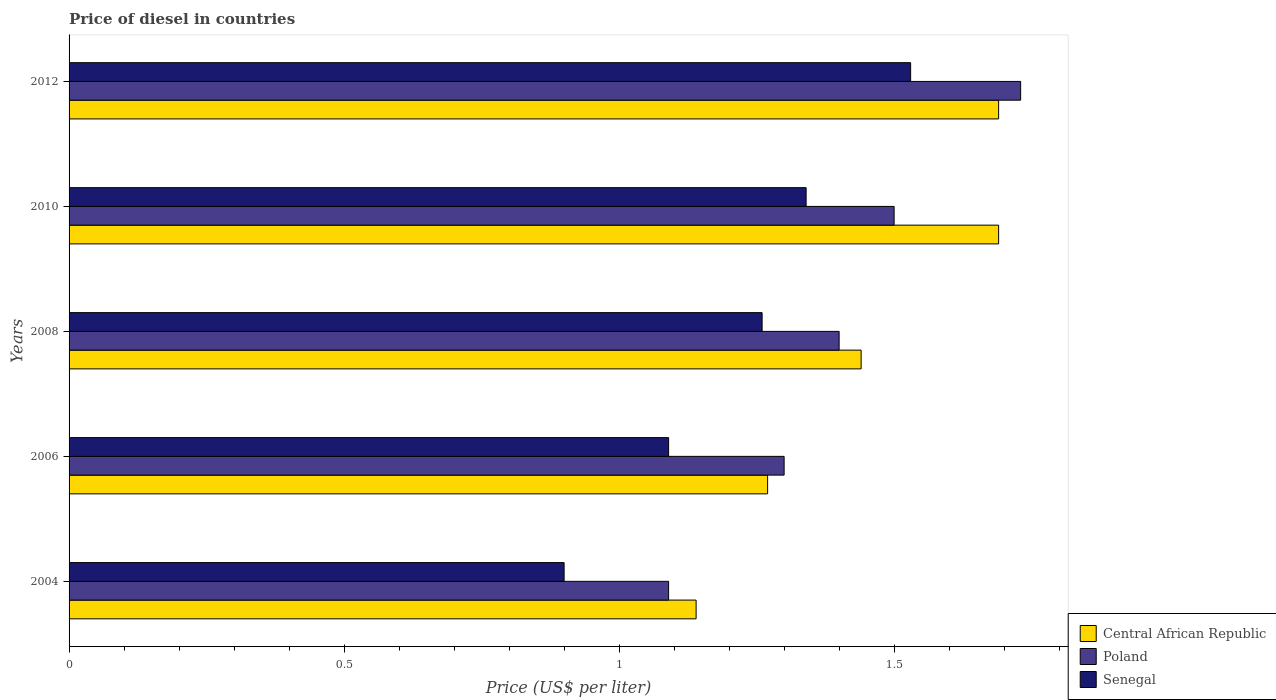How many groups of bars are there?
Offer a very short reply. 5. How many bars are there on the 2nd tick from the bottom?
Your response must be concise. 3. What is the label of the 4th group of bars from the top?
Your answer should be very brief. 2006. What is the price of diesel in Central African Republic in 2012?
Offer a very short reply. 1.69. Across all years, what is the maximum price of diesel in Senegal?
Offer a terse response. 1.53. Across all years, what is the minimum price of diesel in Central African Republic?
Your response must be concise. 1.14. What is the total price of diesel in Senegal in the graph?
Offer a very short reply. 6.12. What is the difference between the price of diesel in Poland in 2006 and that in 2012?
Your response must be concise. -0.43. What is the difference between the price of diesel in Central African Republic in 2006 and the price of diesel in Senegal in 2008?
Offer a very short reply. 0.01. What is the average price of diesel in Central African Republic per year?
Ensure brevity in your answer.  1.45. In the year 2012, what is the difference between the price of diesel in Poland and price of diesel in Senegal?
Ensure brevity in your answer.  0.2. What is the ratio of the price of diesel in Central African Republic in 2004 to that in 2006?
Offer a very short reply. 0.9. Is the price of diesel in Poland in 2010 less than that in 2012?
Make the answer very short. Yes. Is the difference between the price of diesel in Poland in 2004 and 2006 greater than the difference between the price of diesel in Senegal in 2004 and 2006?
Provide a succinct answer. No. What is the difference between the highest and the second highest price of diesel in Senegal?
Provide a short and direct response. 0.19. What is the difference between the highest and the lowest price of diesel in Poland?
Your response must be concise. 0.64. In how many years, is the price of diesel in Poland greater than the average price of diesel in Poland taken over all years?
Your answer should be compact. 2. Is the sum of the price of diesel in Senegal in 2008 and 2012 greater than the maximum price of diesel in Central African Republic across all years?
Provide a short and direct response. Yes. What does the 3rd bar from the bottom in 2012 represents?
Provide a succinct answer. Senegal. Are the values on the major ticks of X-axis written in scientific E-notation?
Your answer should be compact. No. Where does the legend appear in the graph?
Give a very brief answer. Bottom right. How many legend labels are there?
Offer a terse response. 3. How are the legend labels stacked?
Make the answer very short. Vertical. What is the title of the graph?
Keep it short and to the point. Price of diesel in countries. What is the label or title of the X-axis?
Your response must be concise. Price (US$ per liter). What is the Price (US$ per liter) of Central African Republic in 2004?
Keep it short and to the point. 1.14. What is the Price (US$ per liter) of Poland in 2004?
Make the answer very short. 1.09. What is the Price (US$ per liter) in Senegal in 2004?
Provide a short and direct response. 0.9. What is the Price (US$ per liter) in Central African Republic in 2006?
Offer a very short reply. 1.27. What is the Price (US$ per liter) in Senegal in 2006?
Provide a short and direct response. 1.09. What is the Price (US$ per liter) of Central African Republic in 2008?
Your answer should be very brief. 1.44. What is the Price (US$ per liter) of Senegal in 2008?
Your answer should be very brief. 1.26. What is the Price (US$ per liter) of Central African Republic in 2010?
Provide a succinct answer. 1.69. What is the Price (US$ per liter) of Poland in 2010?
Offer a very short reply. 1.5. What is the Price (US$ per liter) in Senegal in 2010?
Give a very brief answer. 1.34. What is the Price (US$ per liter) of Central African Republic in 2012?
Provide a short and direct response. 1.69. What is the Price (US$ per liter) in Poland in 2012?
Offer a terse response. 1.73. What is the Price (US$ per liter) in Senegal in 2012?
Your response must be concise. 1.53. Across all years, what is the maximum Price (US$ per liter) of Central African Republic?
Provide a succinct answer. 1.69. Across all years, what is the maximum Price (US$ per liter) of Poland?
Offer a terse response. 1.73. Across all years, what is the maximum Price (US$ per liter) of Senegal?
Give a very brief answer. 1.53. Across all years, what is the minimum Price (US$ per liter) in Central African Republic?
Give a very brief answer. 1.14. Across all years, what is the minimum Price (US$ per liter) in Poland?
Ensure brevity in your answer.  1.09. What is the total Price (US$ per liter) of Central African Republic in the graph?
Provide a succinct answer. 7.23. What is the total Price (US$ per liter) of Poland in the graph?
Your answer should be compact. 7.02. What is the total Price (US$ per liter) of Senegal in the graph?
Make the answer very short. 6.12. What is the difference between the Price (US$ per liter) of Central African Republic in 2004 and that in 2006?
Offer a terse response. -0.13. What is the difference between the Price (US$ per liter) of Poland in 2004 and that in 2006?
Provide a succinct answer. -0.21. What is the difference between the Price (US$ per liter) in Senegal in 2004 and that in 2006?
Ensure brevity in your answer.  -0.19. What is the difference between the Price (US$ per liter) of Central African Republic in 2004 and that in 2008?
Offer a terse response. -0.3. What is the difference between the Price (US$ per liter) in Poland in 2004 and that in 2008?
Keep it short and to the point. -0.31. What is the difference between the Price (US$ per liter) in Senegal in 2004 and that in 2008?
Provide a succinct answer. -0.36. What is the difference between the Price (US$ per liter) in Central African Republic in 2004 and that in 2010?
Your answer should be compact. -0.55. What is the difference between the Price (US$ per liter) of Poland in 2004 and that in 2010?
Ensure brevity in your answer.  -0.41. What is the difference between the Price (US$ per liter) in Senegal in 2004 and that in 2010?
Make the answer very short. -0.44. What is the difference between the Price (US$ per liter) in Central African Republic in 2004 and that in 2012?
Give a very brief answer. -0.55. What is the difference between the Price (US$ per liter) in Poland in 2004 and that in 2012?
Ensure brevity in your answer.  -0.64. What is the difference between the Price (US$ per liter) of Senegal in 2004 and that in 2012?
Your answer should be compact. -0.63. What is the difference between the Price (US$ per liter) of Central African Republic in 2006 and that in 2008?
Offer a very short reply. -0.17. What is the difference between the Price (US$ per liter) in Senegal in 2006 and that in 2008?
Provide a short and direct response. -0.17. What is the difference between the Price (US$ per liter) in Central African Republic in 2006 and that in 2010?
Give a very brief answer. -0.42. What is the difference between the Price (US$ per liter) of Poland in 2006 and that in 2010?
Offer a terse response. -0.2. What is the difference between the Price (US$ per liter) of Central African Republic in 2006 and that in 2012?
Ensure brevity in your answer.  -0.42. What is the difference between the Price (US$ per liter) in Poland in 2006 and that in 2012?
Keep it short and to the point. -0.43. What is the difference between the Price (US$ per liter) in Senegal in 2006 and that in 2012?
Your answer should be very brief. -0.44. What is the difference between the Price (US$ per liter) of Central African Republic in 2008 and that in 2010?
Provide a short and direct response. -0.25. What is the difference between the Price (US$ per liter) of Poland in 2008 and that in 2010?
Offer a very short reply. -0.1. What is the difference between the Price (US$ per liter) of Senegal in 2008 and that in 2010?
Your answer should be very brief. -0.08. What is the difference between the Price (US$ per liter) in Central African Republic in 2008 and that in 2012?
Offer a very short reply. -0.25. What is the difference between the Price (US$ per liter) in Poland in 2008 and that in 2012?
Your answer should be compact. -0.33. What is the difference between the Price (US$ per liter) of Senegal in 2008 and that in 2012?
Provide a succinct answer. -0.27. What is the difference between the Price (US$ per liter) of Central African Republic in 2010 and that in 2012?
Give a very brief answer. 0. What is the difference between the Price (US$ per liter) in Poland in 2010 and that in 2012?
Your response must be concise. -0.23. What is the difference between the Price (US$ per liter) of Senegal in 2010 and that in 2012?
Keep it short and to the point. -0.19. What is the difference between the Price (US$ per liter) in Central African Republic in 2004 and the Price (US$ per liter) in Poland in 2006?
Your answer should be very brief. -0.16. What is the difference between the Price (US$ per liter) in Central African Republic in 2004 and the Price (US$ per liter) in Poland in 2008?
Keep it short and to the point. -0.26. What is the difference between the Price (US$ per liter) of Central African Republic in 2004 and the Price (US$ per liter) of Senegal in 2008?
Give a very brief answer. -0.12. What is the difference between the Price (US$ per liter) in Poland in 2004 and the Price (US$ per liter) in Senegal in 2008?
Your answer should be compact. -0.17. What is the difference between the Price (US$ per liter) of Central African Republic in 2004 and the Price (US$ per liter) of Poland in 2010?
Make the answer very short. -0.36. What is the difference between the Price (US$ per liter) of Poland in 2004 and the Price (US$ per liter) of Senegal in 2010?
Ensure brevity in your answer.  -0.25. What is the difference between the Price (US$ per liter) of Central African Republic in 2004 and the Price (US$ per liter) of Poland in 2012?
Keep it short and to the point. -0.59. What is the difference between the Price (US$ per liter) in Central African Republic in 2004 and the Price (US$ per liter) in Senegal in 2012?
Your answer should be very brief. -0.39. What is the difference between the Price (US$ per liter) in Poland in 2004 and the Price (US$ per liter) in Senegal in 2012?
Offer a terse response. -0.44. What is the difference between the Price (US$ per liter) in Central African Republic in 2006 and the Price (US$ per liter) in Poland in 2008?
Your response must be concise. -0.13. What is the difference between the Price (US$ per liter) in Poland in 2006 and the Price (US$ per liter) in Senegal in 2008?
Provide a succinct answer. 0.04. What is the difference between the Price (US$ per liter) in Central African Republic in 2006 and the Price (US$ per liter) in Poland in 2010?
Provide a succinct answer. -0.23. What is the difference between the Price (US$ per liter) in Central African Republic in 2006 and the Price (US$ per liter) in Senegal in 2010?
Give a very brief answer. -0.07. What is the difference between the Price (US$ per liter) in Poland in 2006 and the Price (US$ per liter) in Senegal in 2010?
Your response must be concise. -0.04. What is the difference between the Price (US$ per liter) of Central African Republic in 2006 and the Price (US$ per liter) of Poland in 2012?
Make the answer very short. -0.46. What is the difference between the Price (US$ per liter) of Central African Republic in 2006 and the Price (US$ per liter) of Senegal in 2012?
Your answer should be compact. -0.26. What is the difference between the Price (US$ per liter) in Poland in 2006 and the Price (US$ per liter) in Senegal in 2012?
Provide a short and direct response. -0.23. What is the difference between the Price (US$ per liter) in Central African Republic in 2008 and the Price (US$ per liter) in Poland in 2010?
Your answer should be compact. -0.06. What is the difference between the Price (US$ per liter) in Poland in 2008 and the Price (US$ per liter) in Senegal in 2010?
Your answer should be compact. 0.06. What is the difference between the Price (US$ per liter) in Central African Republic in 2008 and the Price (US$ per liter) in Poland in 2012?
Your answer should be very brief. -0.29. What is the difference between the Price (US$ per liter) in Central African Republic in 2008 and the Price (US$ per liter) in Senegal in 2012?
Give a very brief answer. -0.09. What is the difference between the Price (US$ per liter) in Poland in 2008 and the Price (US$ per liter) in Senegal in 2012?
Keep it short and to the point. -0.13. What is the difference between the Price (US$ per liter) in Central African Republic in 2010 and the Price (US$ per liter) in Poland in 2012?
Keep it short and to the point. -0.04. What is the difference between the Price (US$ per liter) in Central African Republic in 2010 and the Price (US$ per liter) in Senegal in 2012?
Your answer should be compact. 0.16. What is the difference between the Price (US$ per liter) in Poland in 2010 and the Price (US$ per liter) in Senegal in 2012?
Your answer should be compact. -0.03. What is the average Price (US$ per liter) of Central African Republic per year?
Provide a succinct answer. 1.45. What is the average Price (US$ per liter) in Poland per year?
Ensure brevity in your answer.  1.4. What is the average Price (US$ per liter) in Senegal per year?
Offer a terse response. 1.22. In the year 2004, what is the difference between the Price (US$ per liter) in Central African Republic and Price (US$ per liter) in Poland?
Provide a succinct answer. 0.05. In the year 2004, what is the difference between the Price (US$ per liter) of Central African Republic and Price (US$ per liter) of Senegal?
Your response must be concise. 0.24. In the year 2004, what is the difference between the Price (US$ per liter) in Poland and Price (US$ per liter) in Senegal?
Make the answer very short. 0.19. In the year 2006, what is the difference between the Price (US$ per liter) of Central African Republic and Price (US$ per liter) of Poland?
Offer a very short reply. -0.03. In the year 2006, what is the difference between the Price (US$ per liter) in Central African Republic and Price (US$ per liter) in Senegal?
Provide a short and direct response. 0.18. In the year 2006, what is the difference between the Price (US$ per liter) of Poland and Price (US$ per liter) of Senegal?
Offer a terse response. 0.21. In the year 2008, what is the difference between the Price (US$ per liter) in Central African Republic and Price (US$ per liter) in Poland?
Your answer should be very brief. 0.04. In the year 2008, what is the difference between the Price (US$ per liter) in Central African Republic and Price (US$ per liter) in Senegal?
Give a very brief answer. 0.18. In the year 2008, what is the difference between the Price (US$ per liter) of Poland and Price (US$ per liter) of Senegal?
Offer a terse response. 0.14. In the year 2010, what is the difference between the Price (US$ per liter) of Central African Republic and Price (US$ per liter) of Poland?
Your response must be concise. 0.19. In the year 2010, what is the difference between the Price (US$ per liter) of Poland and Price (US$ per liter) of Senegal?
Ensure brevity in your answer.  0.16. In the year 2012, what is the difference between the Price (US$ per liter) in Central African Republic and Price (US$ per liter) in Poland?
Your answer should be compact. -0.04. In the year 2012, what is the difference between the Price (US$ per liter) of Central African Republic and Price (US$ per liter) of Senegal?
Make the answer very short. 0.16. In the year 2012, what is the difference between the Price (US$ per liter) of Poland and Price (US$ per liter) of Senegal?
Make the answer very short. 0.2. What is the ratio of the Price (US$ per liter) in Central African Republic in 2004 to that in 2006?
Ensure brevity in your answer.  0.9. What is the ratio of the Price (US$ per liter) of Poland in 2004 to that in 2006?
Provide a short and direct response. 0.84. What is the ratio of the Price (US$ per liter) of Senegal in 2004 to that in 2006?
Make the answer very short. 0.83. What is the ratio of the Price (US$ per liter) of Central African Republic in 2004 to that in 2008?
Your response must be concise. 0.79. What is the ratio of the Price (US$ per liter) of Poland in 2004 to that in 2008?
Offer a very short reply. 0.78. What is the ratio of the Price (US$ per liter) in Senegal in 2004 to that in 2008?
Your response must be concise. 0.71. What is the ratio of the Price (US$ per liter) in Central African Republic in 2004 to that in 2010?
Keep it short and to the point. 0.67. What is the ratio of the Price (US$ per liter) in Poland in 2004 to that in 2010?
Provide a succinct answer. 0.73. What is the ratio of the Price (US$ per liter) of Senegal in 2004 to that in 2010?
Provide a succinct answer. 0.67. What is the ratio of the Price (US$ per liter) of Central African Republic in 2004 to that in 2012?
Keep it short and to the point. 0.67. What is the ratio of the Price (US$ per liter) in Poland in 2004 to that in 2012?
Give a very brief answer. 0.63. What is the ratio of the Price (US$ per liter) in Senegal in 2004 to that in 2012?
Offer a terse response. 0.59. What is the ratio of the Price (US$ per liter) in Central African Republic in 2006 to that in 2008?
Offer a very short reply. 0.88. What is the ratio of the Price (US$ per liter) of Senegal in 2006 to that in 2008?
Offer a terse response. 0.87. What is the ratio of the Price (US$ per liter) in Central African Republic in 2006 to that in 2010?
Your answer should be very brief. 0.75. What is the ratio of the Price (US$ per liter) of Poland in 2006 to that in 2010?
Your response must be concise. 0.87. What is the ratio of the Price (US$ per liter) of Senegal in 2006 to that in 2010?
Offer a terse response. 0.81. What is the ratio of the Price (US$ per liter) of Central African Republic in 2006 to that in 2012?
Keep it short and to the point. 0.75. What is the ratio of the Price (US$ per liter) in Poland in 2006 to that in 2012?
Keep it short and to the point. 0.75. What is the ratio of the Price (US$ per liter) of Senegal in 2006 to that in 2012?
Provide a succinct answer. 0.71. What is the ratio of the Price (US$ per liter) of Central African Republic in 2008 to that in 2010?
Offer a terse response. 0.85. What is the ratio of the Price (US$ per liter) of Poland in 2008 to that in 2010?
Make the answer very short. 0.93. What is the ratio of the Price (US$ per liter) in Senegal in 2008 to that in 2010?
Offer a terse response. 0.94. What is the ratio of the Price (US$ per liter) of Central African Republic in 2008 to that in 2012?
Provide a short and direct response. 0.85. What is the ratio of the Price (US$ per liter) in Poland in 2008 to that in 2012?
Keep it short and to the point. 0.81. What is the ratio of the Price (US$ per liter) of Senegal in 2008 to that in 2012?
Provide a short and direct response. 0.82. What is the ratio of the Price (US$ per liter) in Central African Republic in 2010 to that in 2012?
Make the answer very short. 1. What is the ratio of the Price (US$ per liter) in Poland in 2010 to that in 2012?
Your answer should be compact. 0.87. What is the ratio of the Price (US$ per liter) of Senegal in 2010 to that in 2012?
Ensure brevity in your answer.  0.88. What is the difference between the highest and the second highest Price (US$ per liter) of Central African Republic?
Provide a short and direct response. 0. What is the difference between the highest and the second highest Price (US$ per liter) in Poland?
Ensure brevity in your answer.  0.23. What is the difference between the highest and the second highest Price (US$ per liter) of Senegal?
Your answer should be very brief. 0.19. What is the difference between the highest and the lowest Price (US$ per liter) in Central African Republic?
Provide a short and direct response. 0.55. What is the difference between the highest and the lowest Price (US$ per liter) of Poland?
Provide a short and direct response. 0.64. What is the difference between the highest and the lowest Price (US$ per liter) of Senegal?
Make the answer very short. 0.63. 